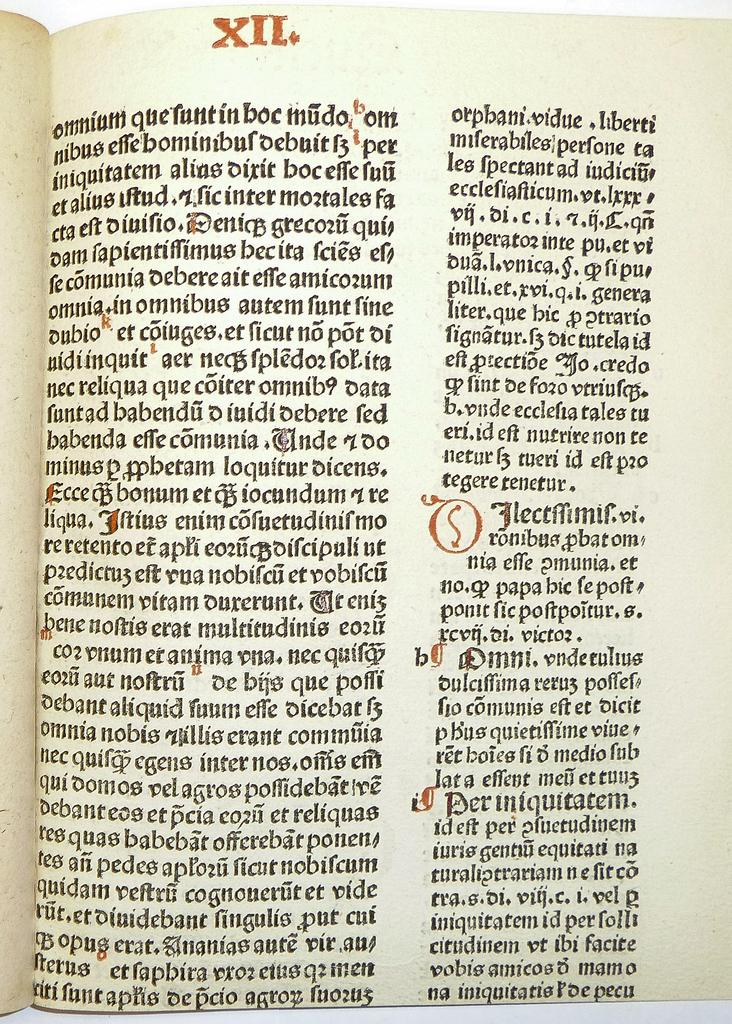What is the main subject of the image? The main subject of the image is a page. What can be seen on the page? There is writing on the page. Is there any specific identifier on the page? Yes, there is a number plate at the top of the page. What type of cake is being served to the sister in the image? There is no cake or sister present in the image; it only features a page with writing and a number plate. 